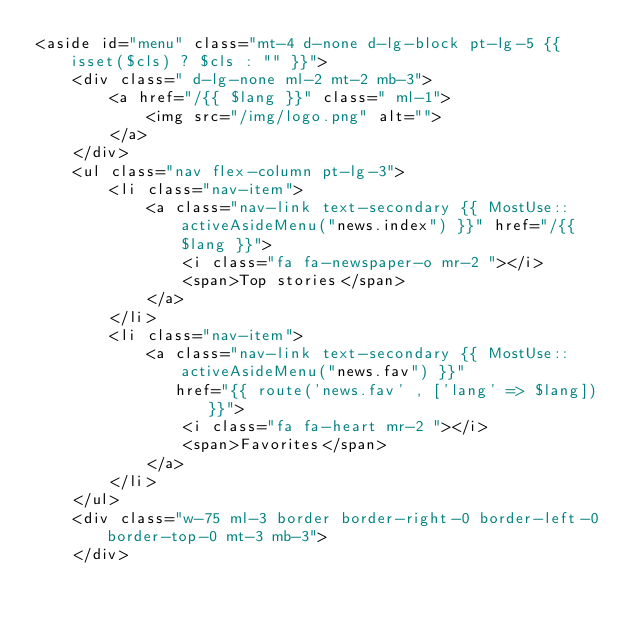<code> <loc_0><loc_0><loc_500><loc_500><_PHP_><aside id="menu" class="mt-4 d-none d-lg-block pt-lg-5 {{ isset($cls) ? $cls : "" }}">
    <div class=" d-lg-none ml-2 mt-2 mb-3">
        <a href="/{{ $lang }}" class=" ml-1">
            <img src="/img/logo.png" alt="">
        </a>
    </div>
    <ul class="nav flex-column pt-lg-3">
        <li class="nav-item">
            <a class="nav-link text-secondary {{ MostUse::activeAsideMenu("news.index") }}" href="/{{ $lang }}">
                <i class="fa fa-newspaper-o mr-2 "></i>
                <span>Top stories</span>
            </a>
        </li>
        <li class="nav-item">
            <a class="nav-link text-secondary {{ MostUse::activeAsideMenu("news.fav") }}"
               href="{{ route('news.fav' , ['lang' => $lang]) }}">
                <i class="fa fa-heart mr-2 "></i>
                <span>Favorites</span>
            </a>
        </li>
    </ul>
    <div class="w-75 ml-3 border border-right-0 border-left-0 border-top-0 mt-3 mb-3">
    </div>
</code> 